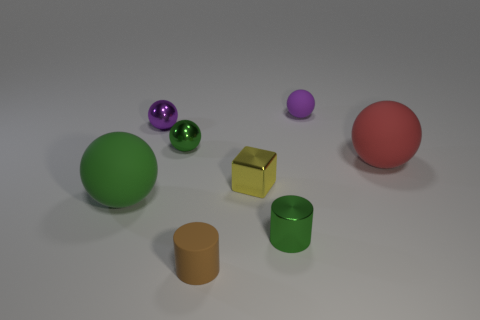Subtract all tiny purple matte balls. How many balls are left? 4 Subtract all red spheres. How many spheres are left? 4 Subtract all yellow spheres. Subtract all purple cubes. How many spheres are left? 5 Add 2 big green things. How many objects exist? 10 Subtract all balls. How many objects are left? 3 Add 3 tiny yellow metallic cubes. How many tiny yellow metallic cubes are left? 4 Add 2 yellow matte cylinders. How many yellow matte cylinders exist? 2 Subtract 0 gray cubes. How many objects are left? 8 Subtract all rubber things. Subtract all tiny cyan blocks. How many objects are left? 4 